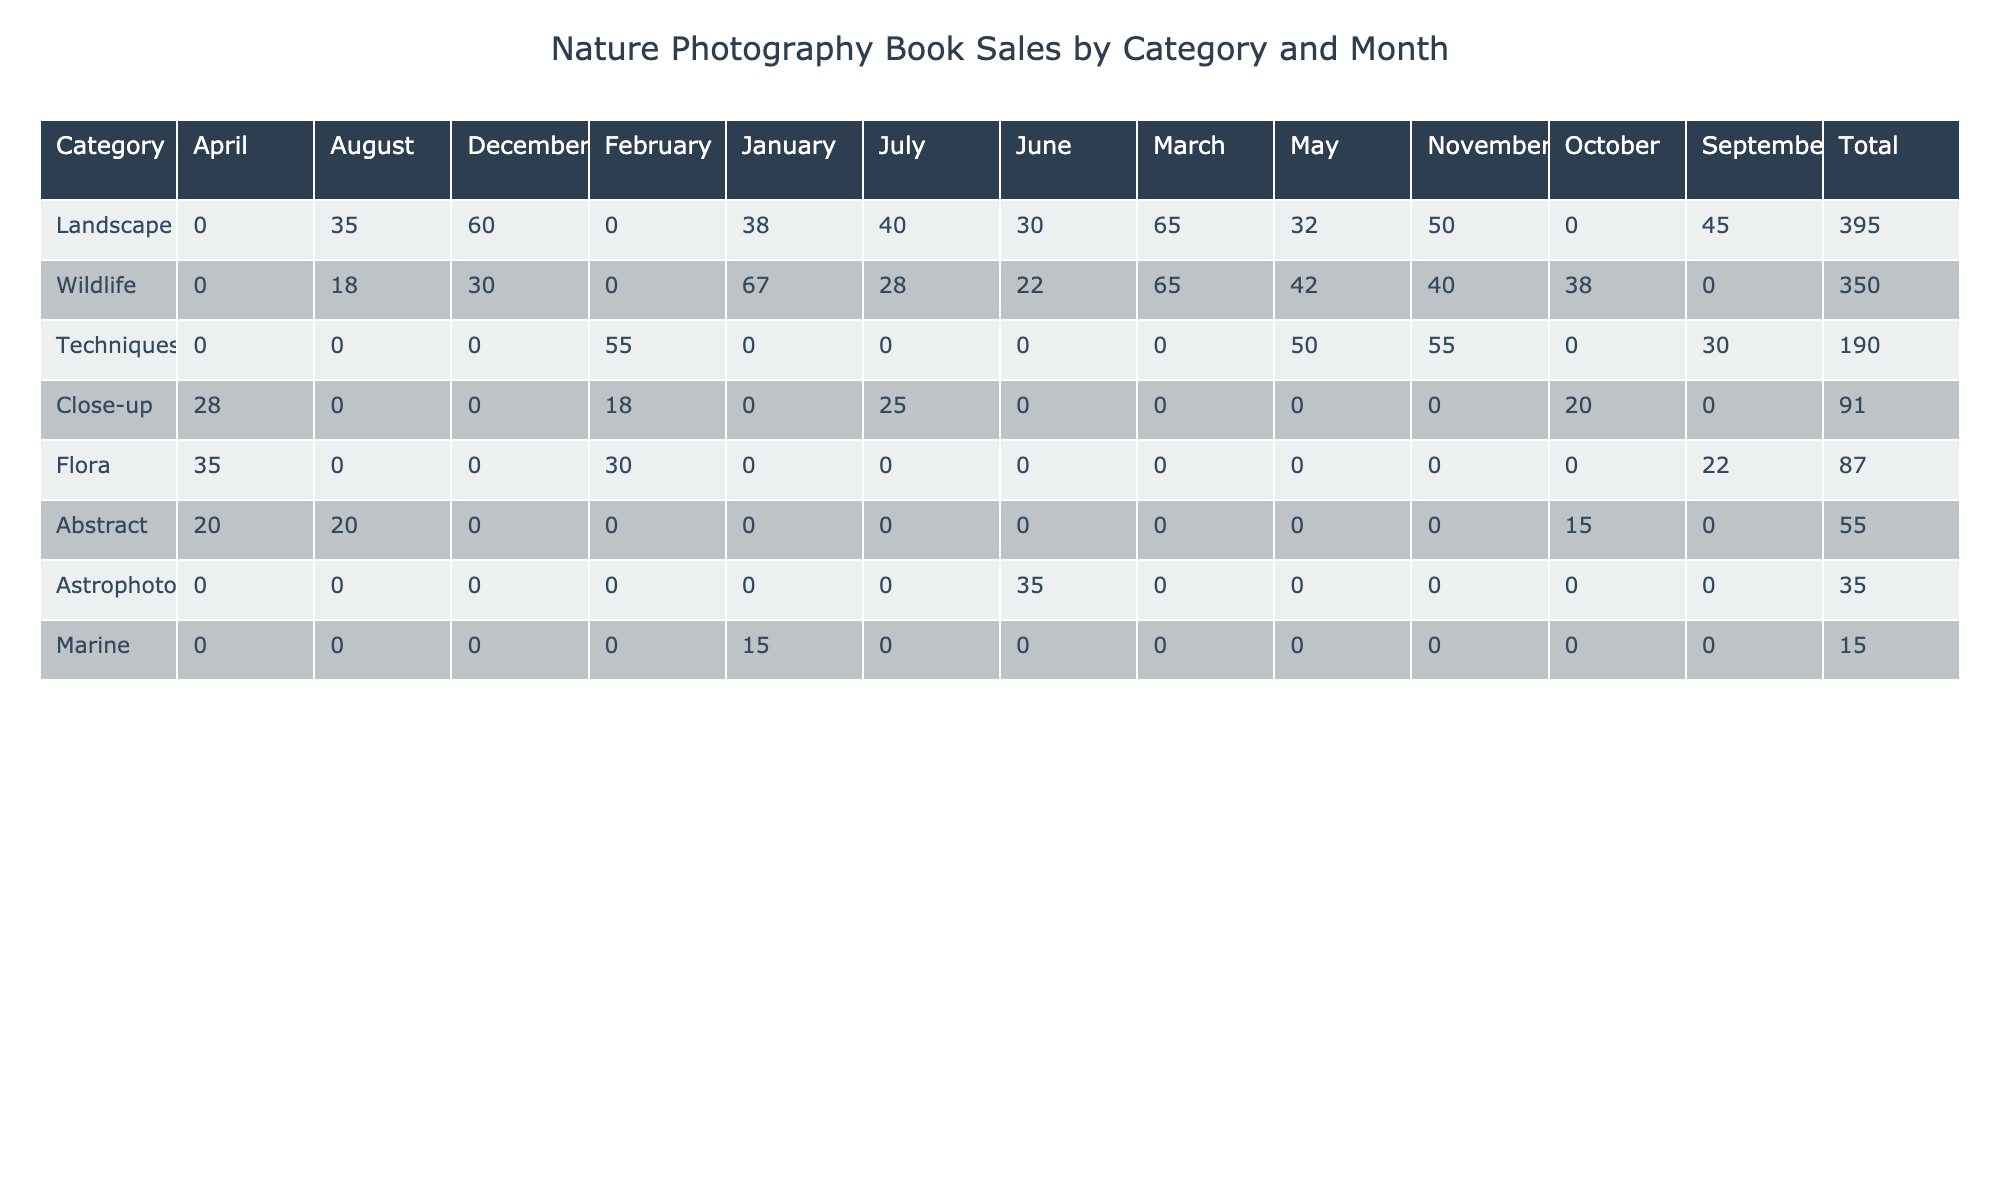What is the total sales for Wildlife books in January? In the January row for the Wildlife category, the sales value is 45. Thus, the total sales for Wildlife books in January is 45.
Answer: 45 Which month had the highest sales for Landscape books? By looking through the monthly columns for Landscape books, the month with the highest sales is September, with 45 sales.
Answer: September What is the average customer rating for all categories in March? The relevant ratings for all categories in March are: National Parks (4.7), Wildlife Photography (4.5), and Mountains (4.6). Adding these gives 4.7 + 4.5 + 4.6 = 13.8. Dividing by the number of entries (3), the average rating is 13.8 / 3 = 4.6.
Answer: 4.6 Did any months have zero sales for any book category? Looking at the table, there are no months listed where any book category has a sales value of zero. Therefore, the answer is false.
Answer: No Which category had the highest total sales overall and what is that total? Summing up each category's total sales, Wildlife has 563, Landscape has 431, Flora has 164, Techniques has 241, Close-up has 93, Marine has 15, and Abstract has 55. The highest is Wildlife with a total of 563.
Answer: Wildlife, 563 What is the difference in sales between the best-selling month and the worst-selling month for Flora books? The total sales for Flora books across the months are: January (0), February (30), March (0), April (35), May (0), June (0), July (0), August (0), September (22), October (0), November (0), December (0). The best-selling month is April with 35 sales, and January has 0 sales. The difference is 35 - 0 = 35.
Answer: 35 Which two months had the same sales for Landscape books, and what was that sales figure? Checking the sales values for Landscape books, both August and December have the same sales figure of 35.
Answer: August and December, 35 What percentage of the total sales for Abstract books came from the month of October? The total sales for Abstract books are: Nature's Patterns (20) in April, and Nature's Abstractions (15) in October, totaling to 35 sales. The sales from October, which is 15, results in a percentage of (15/35) * 100 = 42.86%.
Answer: 42.86% How many months had sales greater than 30 for Techniques books? Examining the Techniques category across the months, we find that only three months (February with 55, May with 50, and November with 55) had sales greater than 30. Therefore, the count of months is 3.
Answer: 3 